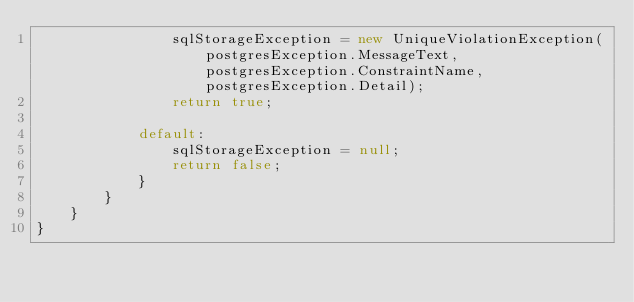<code> <loc_0><loc_0><loc_500><loc_500><_C#_>                sqlStorageException = new UniqueViolationException(postgresException.MessageText, postgresException.ConstraintName, postgresException.Detail);
                return true;

            default:
                sqlStorageException = null;
                return false;
            }
        }
    }
}</code> 